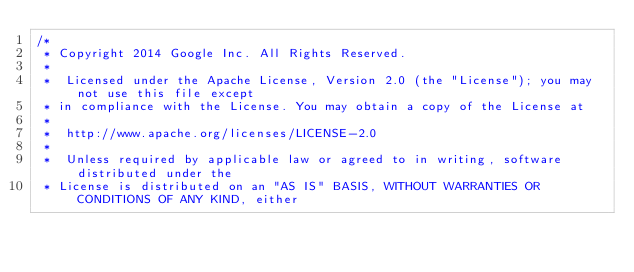Convert code to text. <code><loc_0><loc_0><loc_500><loc_500><_Java_>/*
 * Copyright 2014 Google Inc. All Rights Reserved.
 *
 *  Licensed under the Apache License, Version 2.0 (the "License"); you may not use this file except
 * in compliance with the License. You may obtain a copy of the License at
 *
 *  http://www.apache.org/licenses/LICENSE-2.0
 *
 *  Unless required by applicable law or agreed to in writing, software distributed under the
 * License is distributed on an "AS IS" BASIS, WITHOUT WARRANTIES OR CONDITIONS OF ANY KIND, either</code> 